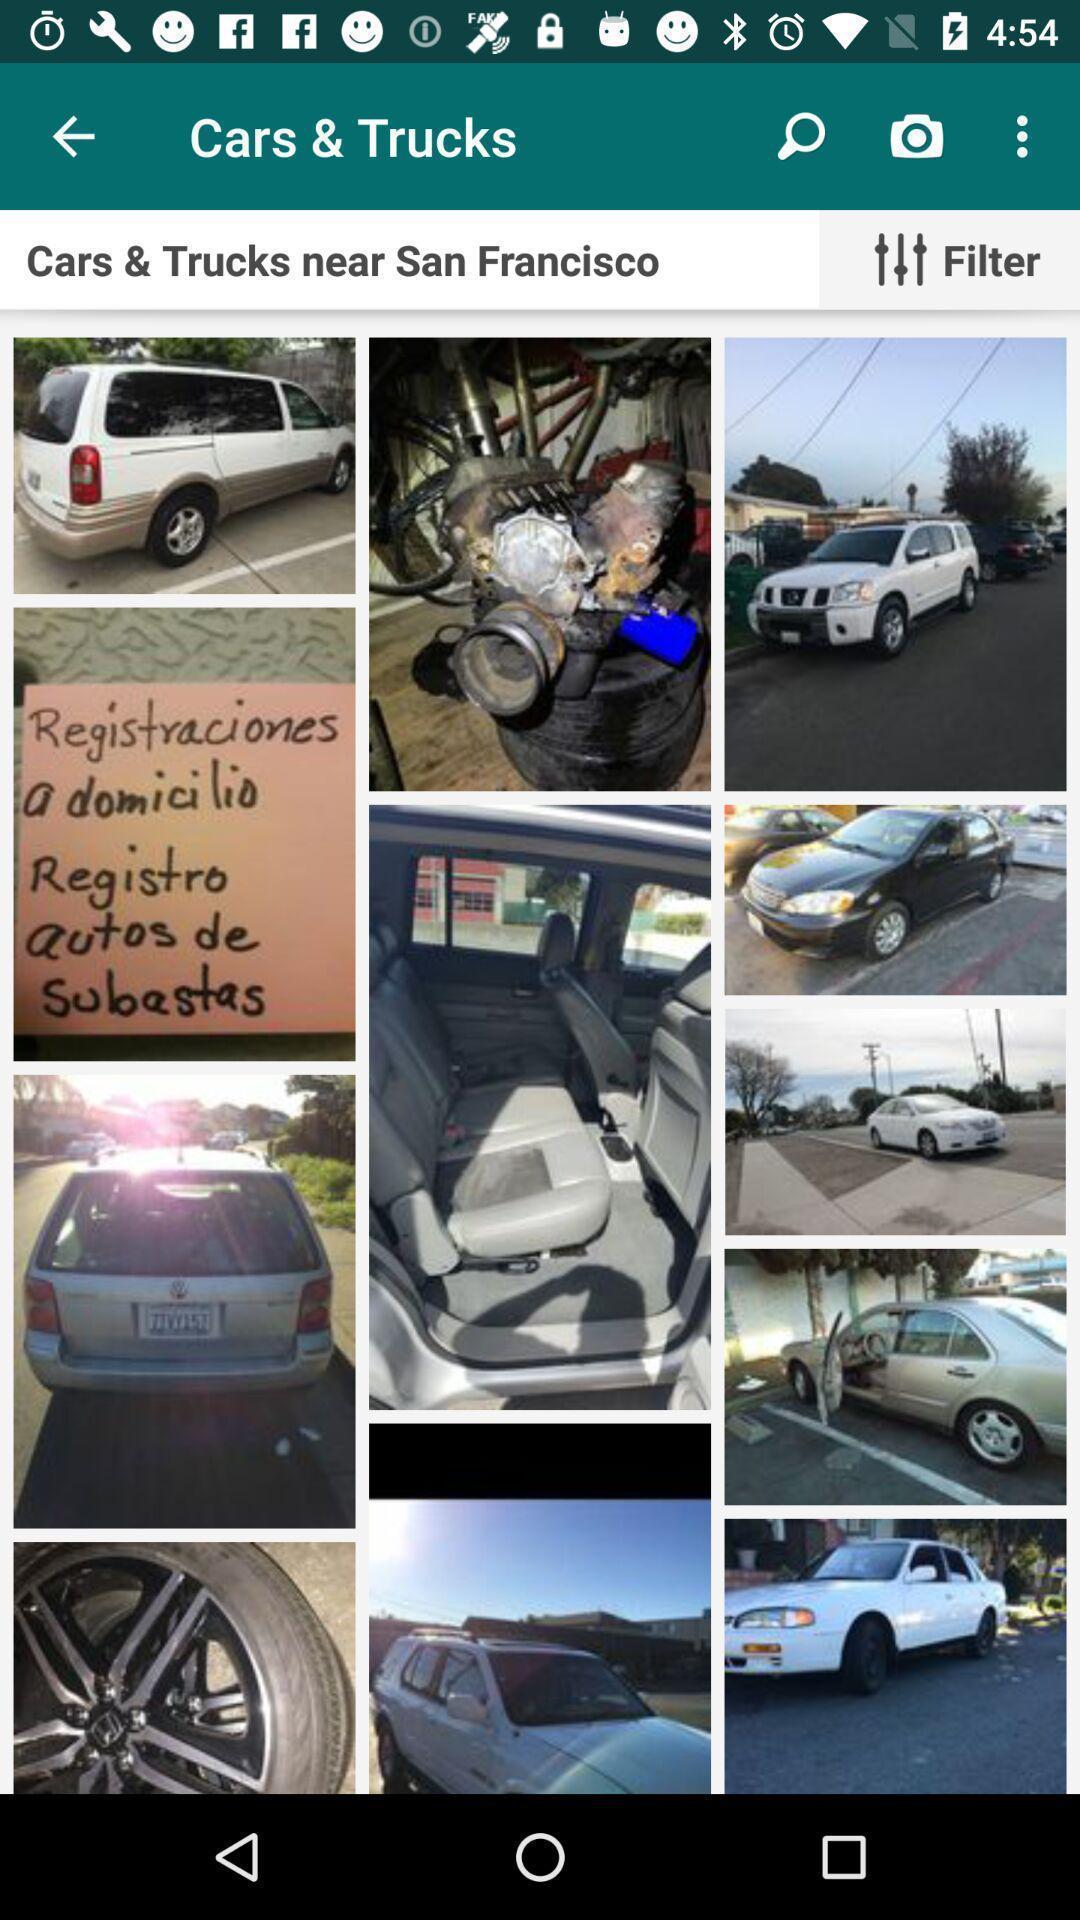What is the overall content of this screenshot? Screen page displaying various images with different options. 